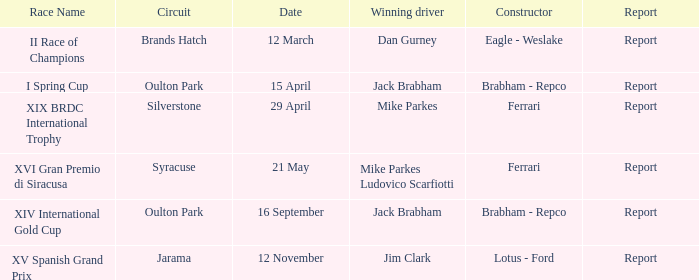What date was the xiv international gold cup? 16 September. 